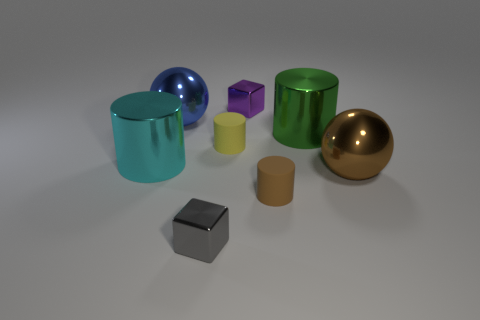How many metal objects are brown balls or cyan cylinders?
Keep it short and to the point. 2. How many large metal things are both behind the tiny yellow rubber thing and left of the brown matte object?
Offer a terse response. 1. Is there anything else that has the same shape as the yellow matte thing?
Give a very brief answer. Yes. What number of other objects are there of the same size as the cyan metal cylinder?
Provide a succinct answer. 3. There is a metal cube that is behind the blue metallic object; is its size the same as the metallic cylinder that is in front of the tiny yellow matte object?
Offer a terse response. No. What number of things are tiny gray things or big things to the right of the tiny gray metal block?
Keep it short and to the point. 3. How big is the ball that is in front of the blue metal thing?
Your response must be concise. Large. Are there fewer brown metal objects that are on the left side of the large brown shiny ball than gray shiny blocks that are behind the tiny gray cube?
Provide a short and direct response. No. What is the large thing that is in front of the green cylinder and on the left side of the purple shiny object made of?
Your answer should be very brief. Metal. What shape is the tiny object in front of the small rubber cylinder that is in front of the large brown thing?
Keep it short and to the point. Cube. 